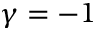<formula> <loc_0><loc_0><loc_500><loc_500>\gamma = - 1</formula> 